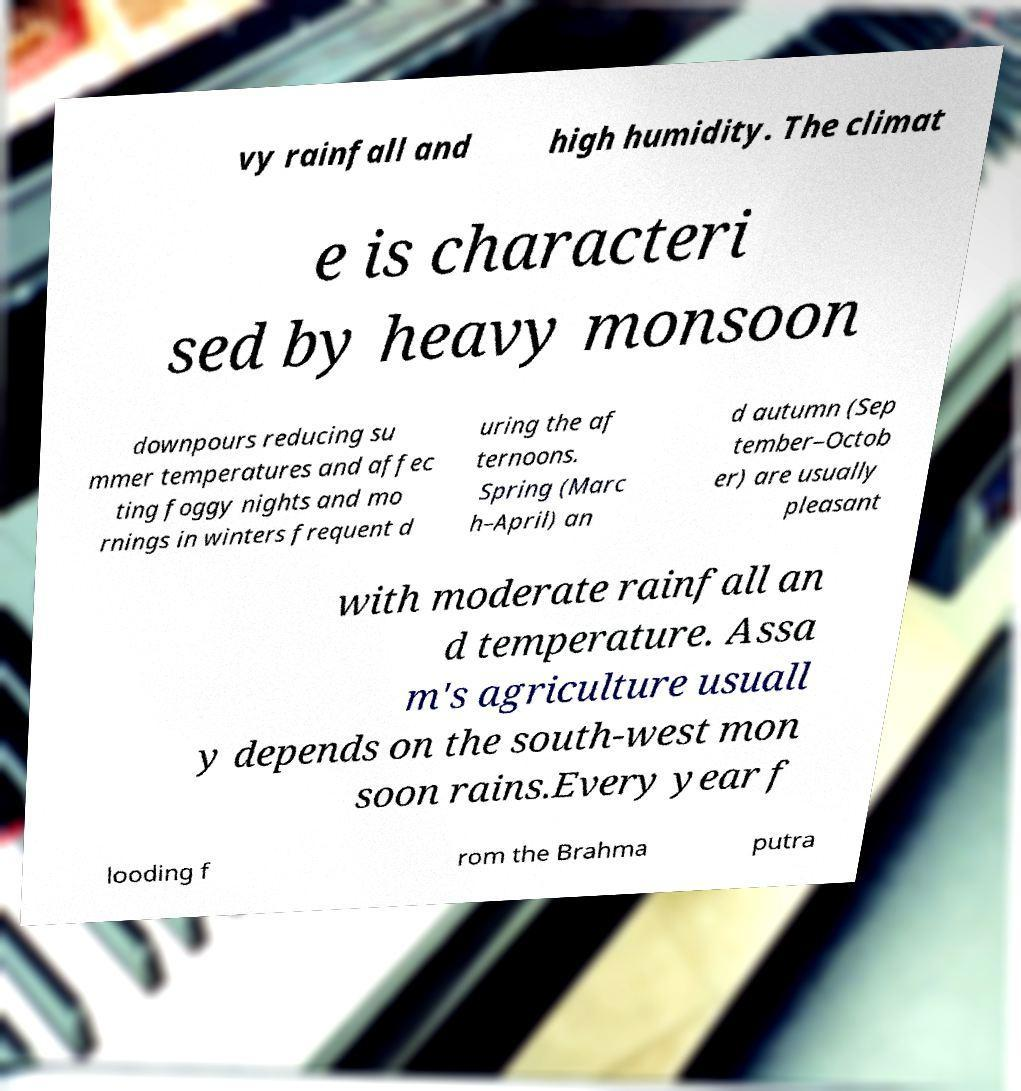Can you accurately transcribe the text from the provided image for me? vy rainfall and high humidity. The climat e is characteri sed by heavy monsoon downpours reducing su mmer temperatures and affec ting foggy nights and mo rnings in winters frequent d uring the af ternoons. Spring (Marc h–April) an d autumn (Sep tember–Octob er) are usually pleasant with moderate rainfall an d temperature. Assa m's agriculture usuall y depends on the south-west mon soon rains.Every year f looding f rom the Brahma putra 